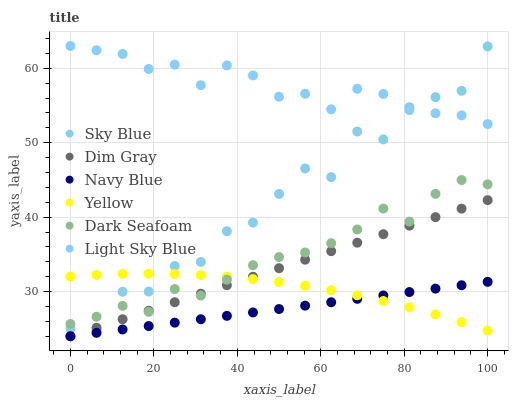Does Navy Blue have the minimum area under the curve?
Answer yes or no. Yes. Does Light Sky Blue have the maximum area under the curve?
Answer yes or no. Yes. Does Yellow have the minimum area under the curve?
Answer yes or no. No. Does Yellow have the maximum area under the curve?
Answer yes or no. No. Is Navy Blue the smoothest?
Answer yes or no. Yes. Is Sky Blue the roughest?
Answer yes or no. Yes. Is Yellow the smoothest?
Answer yes or no. No. Is Yellow the roughest?
Answer yes or no. No. Does Dim Gray have the lowest value?
Answer yes or no. Yes. Does Yellow have the lowest value?
Answer yes or no. No. Does Light Sky Blue have the highest value?
Answer yes or no. Yes. Does Yellow have the highest value?
Answer yes or no. No. Is Dim Gray less than Light Sky Blue?
Answer yes or no. Yes. Is Light Sky Blue greater than Navy Blue?
Answer yes or no. Yes. Does Yellow intersect Dark Seafoam?
Answer yes or no. Yes. Is Yellow less than Dark Seafoam?
Answer yes or no. No. Is Yellow greater than Dark Seafoam?
Answer yes or no. No. Does Dim Gray intersect Light Sky Blue?
Answer yes or no. No. 